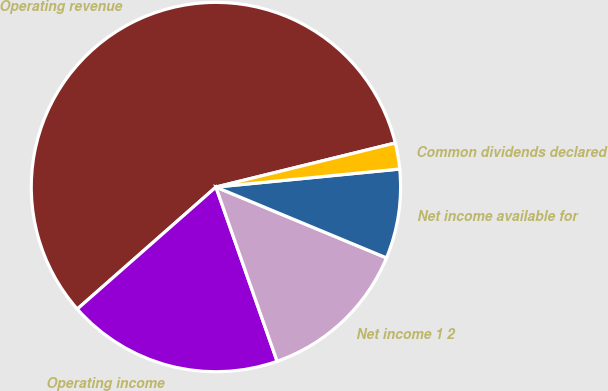Convert chart. <chart><loc_0><loc_0><loc_500><loc_500><pie_chart><fcel>Operating revenue<fcel>Operating income<fcel>Net income 1 2<fcel>Net income available for<fcel>Common dividends declared<nl><fcel>57.65%<fcel>18.89%<fcel>13.36%<fcel>7.82%<fcel>2.28%<nl></chart> 